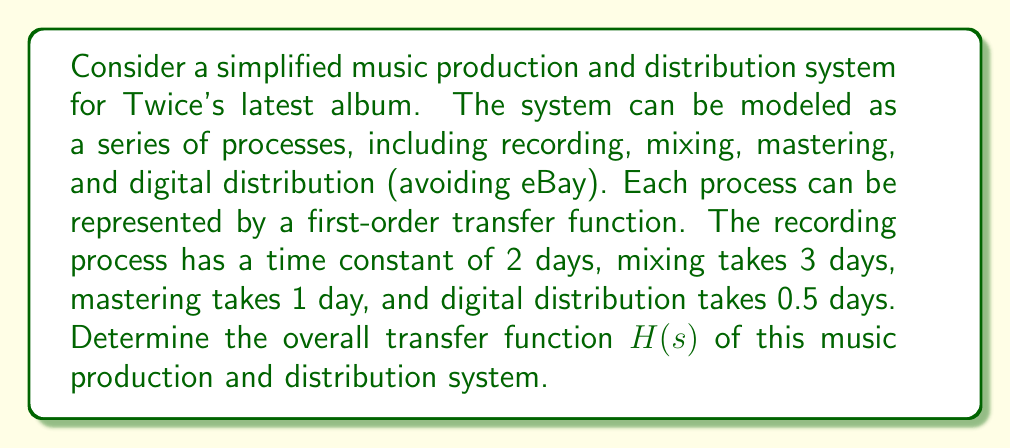Solve this math problem. Let's approach this step-by-step:

1) Each process can be represented by a first-order transfer function of the form:

   $$G(s) = \frac{K}{\tau s + 1}$$

   where $K$ is the gain (assumed to be 1 for each process) and $\tau$ is the time constant.

2) For each process, we have:
   - Recording: $G_1(s) = \frac{1}{2s + 1}$
   - Mixing: $G_2(s) = \frac{1}{3s + 1}$
   - Mastering: $G_3(s) = \frac{1}{s + 1}$
   - Digital distribution: $G_4(s) = \frac{1}{0.5s + 1}$

3) Since these processes are in series, the overall transfer function is the product of individual transfer functions:

   $$H(s) = G_1(s) \cdot G_2(s) \cdot G_3(s) \cdot G_4(s)$$

4) Substituting the individual transfer functions:

   $$H(s) = \frac{1}{2s + 1} \cdot \frac{1}{3s + 1} \cdot \frac{1}{s + 1} \cdot \frac{1}{0.5s + 1}$$

5) Multiplying the denominators:

   $$H(s) = \frac{1}{(2s + 1)(3s + 1)(s + 1)(0.5s + 1)}$$

6) Expanding the denominator:

   $$H(s) = \frac{1}{3s^4 + 13s^3 + 20.5s^2 + 13.5s + 1}$$

This is the overall transfer function of the music production and distribution system for Twice's latest album.
Answer: $$H(s) = \frac{1}{3s^4 + 13s^3 + 20.5s^2 + 13.5s + 1}$$ 